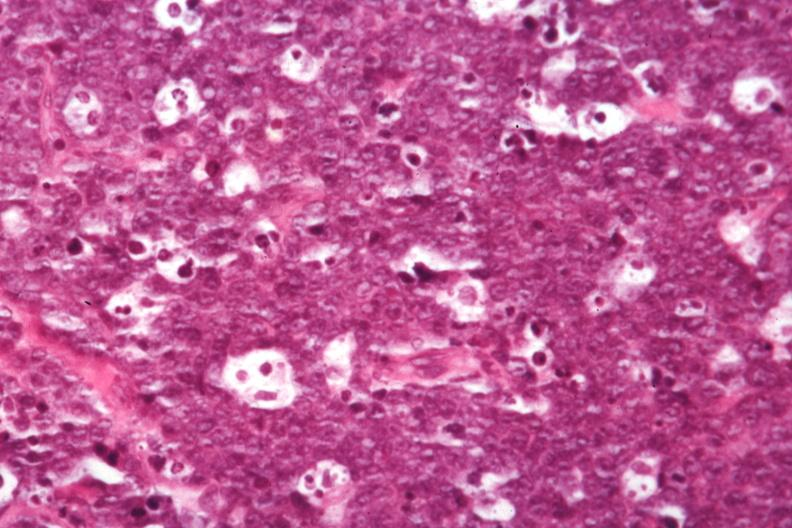what does this image show?
Answer the question using a single word or phrase. Good starry sky detail in large lymphocytes not so good 